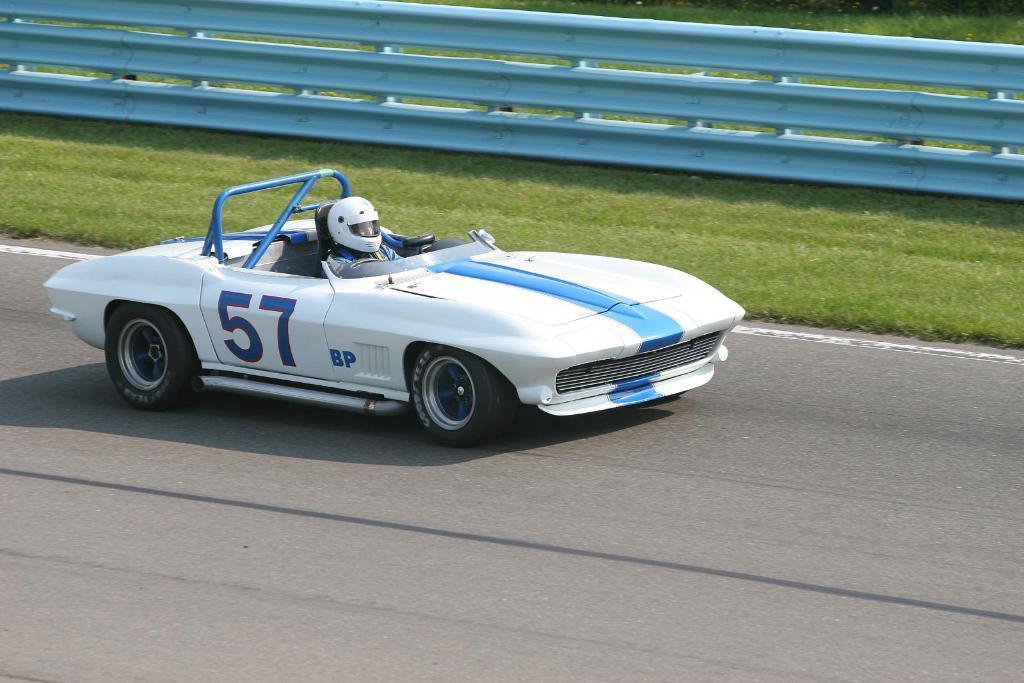Please provide a concise description of this image. In this picture we can observe a white color car moving on the road. There is a person sitting in the car and wearing helmet. There is some grass on the side of the road. We can observe a railing here. 